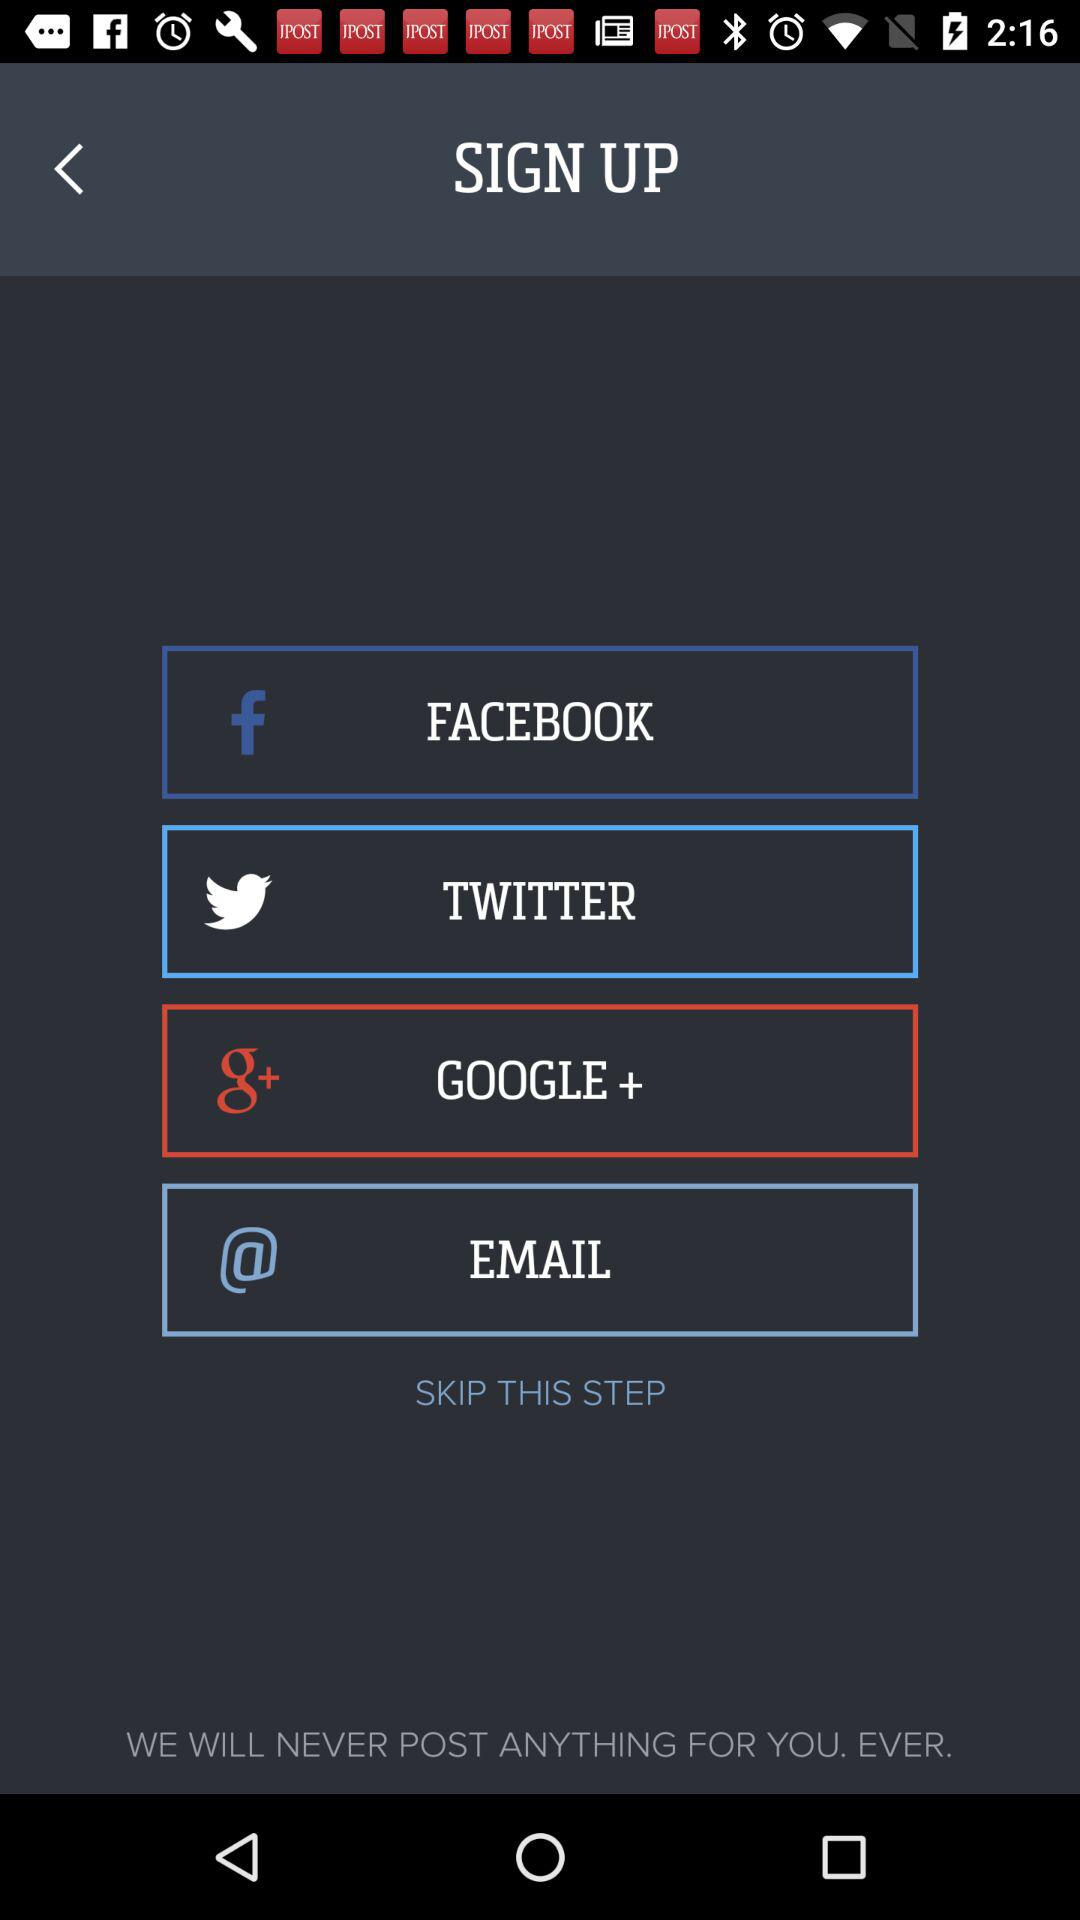What accounts can I use to sign up? The accounts are "FACEBOOK","TWITTER", "GOOGLE+", and "EMAIL". 